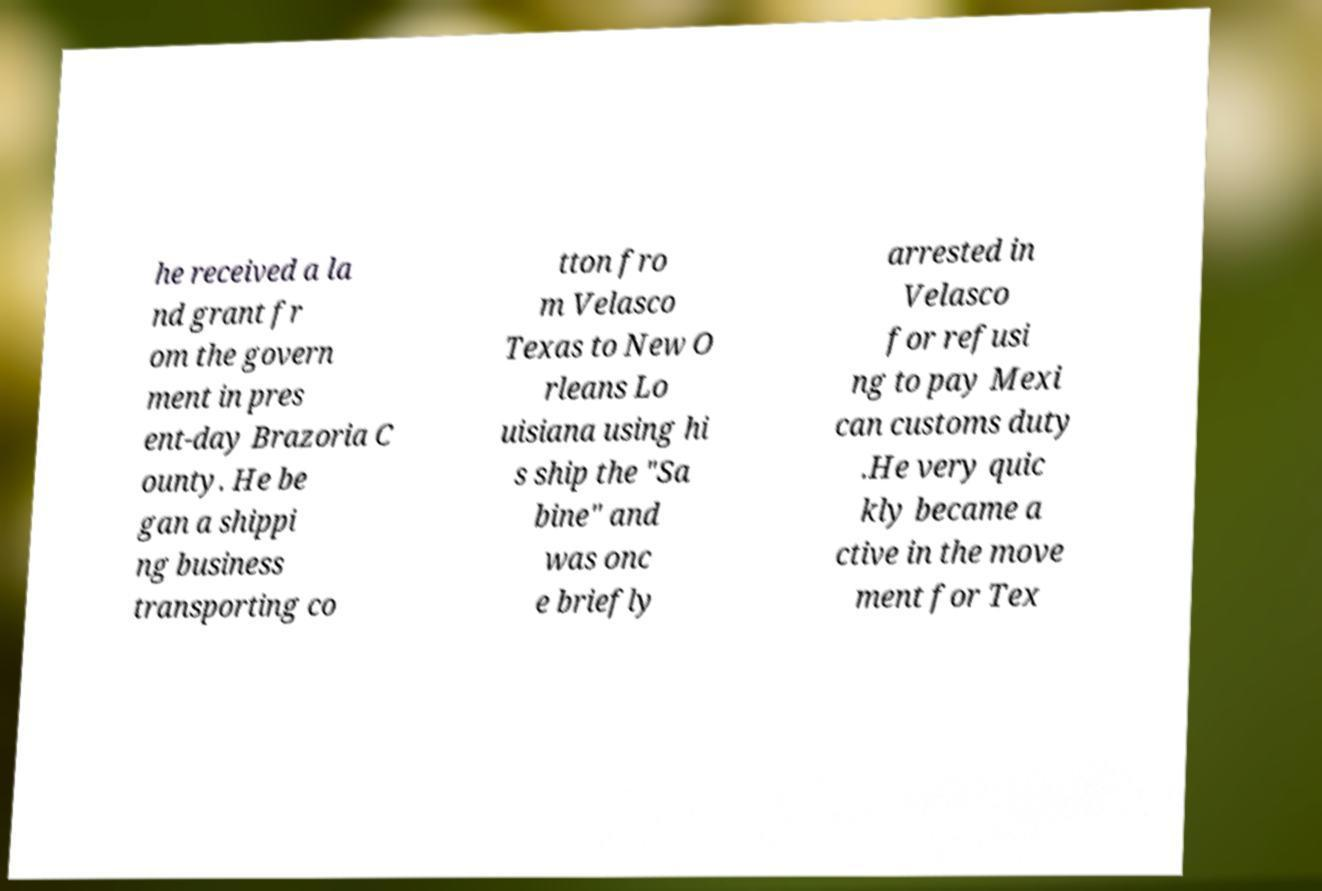Can you read and provide the text displayed in the image?This photo seems to have some interesting text. Can you extract and type it out for me? he received a la nd grant fr om the govern ment in pres ent-day Brazoria C ounty. He be gan a shippi ng business transporting co tton fro m Velasco Texas to New O rleans Lo uisiana using hi s ship the "Sa bine" and was onc e briefly arrested in Velasco for refusi ng to pay Mexi can customs duty .He very quic kly became a ctive in the move ment for Tex 